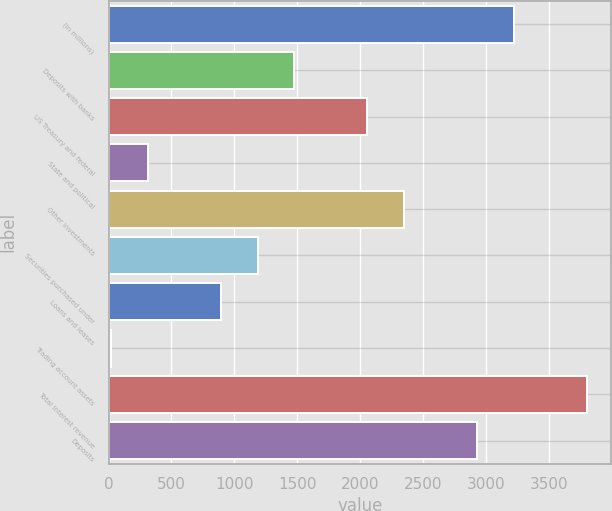Convert chart. <chart><loc_0><loc_0><loc_500><loc_500><bar_chart><fcel>(In millions)<fcel>Deposits with banks<fcel>US Treasury and federal<fcel>State and political<fcel>Other investments<fcel>Securities purchased under<fcel>Loans and leases<fcel>Trading account assets<fcel>Total interest revenue<fcel>Deposits<nl><fcel>3220.9<fcel>1475.5<fcel>2057.3<fcel>311.9<fcel>2348.2<fcel>1184.6<fcel>893.7<fcel>21<fcel>3802.7<fcel>2930<nl></chart> 